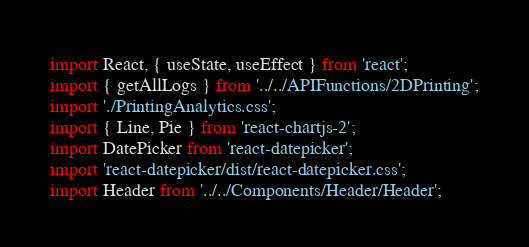<code> <loc_0><loc_0><loc_500><loc_500><_JavaScript_>import React, { useState, useEffect } from 'react';
import { getAllLogs } from '../../APIFunctions/2DPrinting';
import './PrintingAnalytics.css';
import { Line, Pie } from 'react-chartjs-2';
import DatePicker from 'react-datepicker';
import 'react-datepicker/dist/react-datepicker.css';
import Header from '../../Components/Header/Header';</code> 